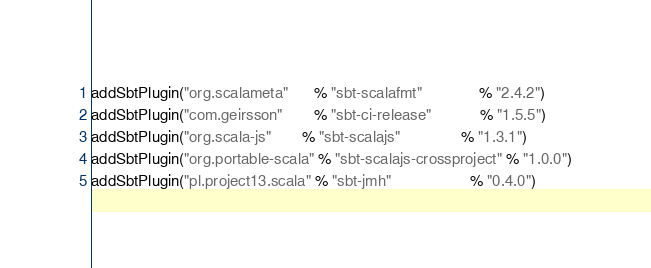<code> <loc_0><loc_0><loc_500><loc_500><_Scala_>addSbtPlugin("org.scalameta"      % "sbt-scalafmt"             % "2.4.2")
addSbtPlugin("com.geirsson"       % "sbt-ci-release"           % "1.5.5")
addSbtPlugin("org.scala-js"       % "sbt-scalajs"              % "1.3.1")
addSbtPlugin("org.portable-scala" % "sbt-scalajs-crossproject" % "1.0.0")
addSbtPlugin("pl.project13.scala" % "sbt-jmh"                  % "0.4.0")
</code> 